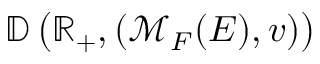<formula> <loc_0><loc_0><loc_500><loc_500>\mathbb { D } \left ( \mathbb { R } _ { + } , ( \mathcal { M } _ { F } ( E ) , v ) \right )</formula> 